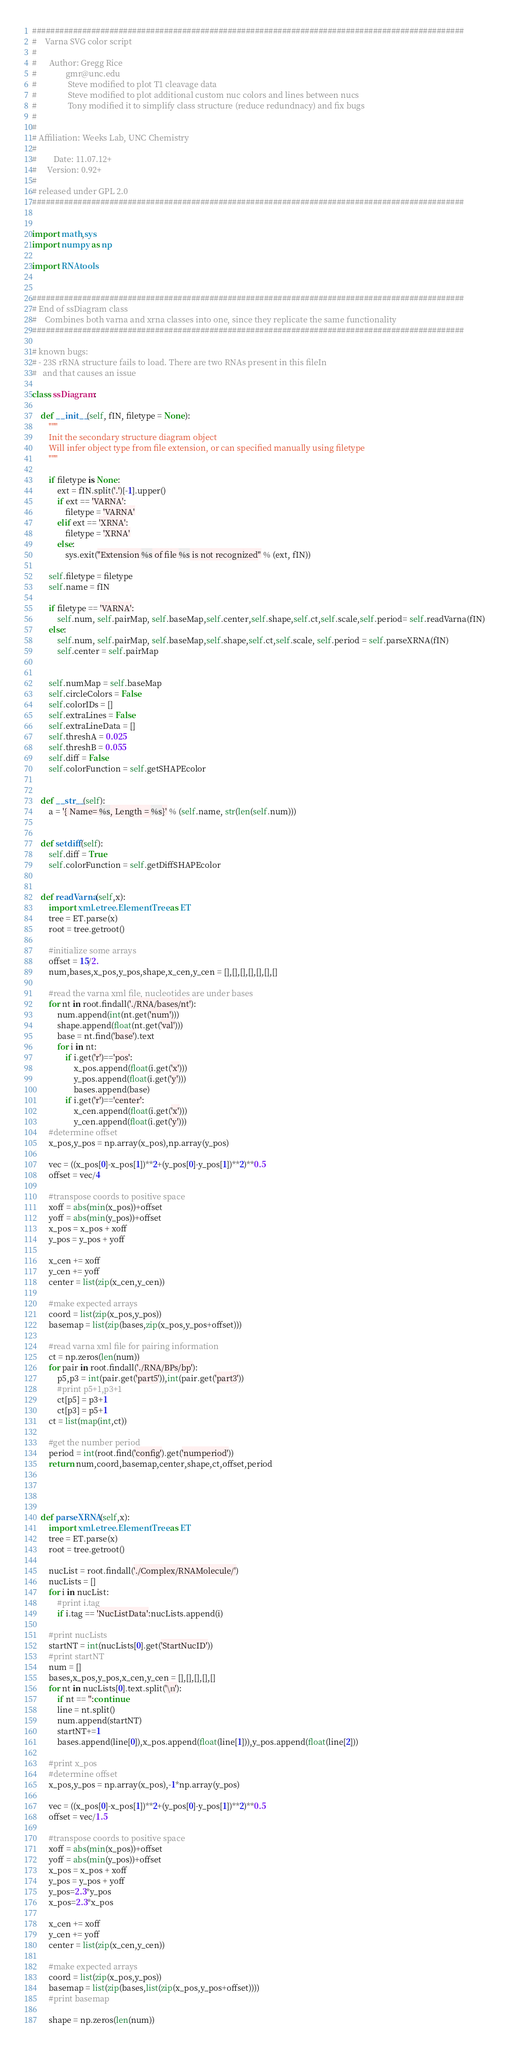<code> <loc_0><loc_0><loc_500><loc_500><_Python_>###############################################################################################
#    Varna SVG color script
#
#      Author: Gregg Rice
#              gmr@unc.edu
#               Steve modified to plot T1 cleavage data
#               Steve modified to plot additional custom nuc colors and lines between nucs
#               Tony modified it to simplify class structure (reduce redundnacy) and fix bugs
#
#
# Affiliation: Weeks Lab, UNC Chemistry
#
#        Date: 11.07.12+
#     Version: 0.92+
#
# released under GPL 2.0
###############################################################################################


import math,sys
import numpy as np

import RNAtools


###############################################################################################
# End of ssDiagram class
#    Combines both varna and xrna classes into one, since they replicate the same functionality
###############################################################################################

# known bugs:
# - 23S rRNA structure fails to load. There are two RNAs present in this fileIn
#   and that causes an issue

class ssDiagram:

    def __init__(self, fIN, filetype = None):
        """
        Init the secondary structure diagram object
        Will infer object type from file extension, or can specified manually using filetype
        """

        if filetype is None:
            ext = fIN.split('.')[-1].upper()
            if ext == 'VARNA':
                filetype = 'VARNA'
            elif ext == 'XRNA':
                filetype = 'XRNA'
            else:
                sys.exit("Extension %s of file %s is not recognized" % (ext, fIN))

        self.filetype = filetype
        self.name = fIN

        if filetype == 'VARNA':
            self.num, self.pairMap, self.baseMap,self.center,self.shape,self.ct,self.scale,self.period= self.readVarna(fIN)
        else:
            self.num, self.pairMap, self.baseMap,self.shape,self.ct,self.scale, self.period = self.parseXRNA(fIN)
            self.center = self.pairMap


        self.numMap = self.baseMap
        self.circleColors = False
        self.colorIDs = []
        self.extraLines = False
        self.extraLineData = []
        self.threshA = 0.025
        self.threshB = 0.055
        self.diff = False
        self.colorFunction = self.getSHAPEcolor


    def __str__(self):
        a = '{ Name= %s, Length = %s}' % (self.name, str(len(self.num)))


    def setdiff(self):
        self.diff = True
        self.colorFunction = self.getDiffSHAPEcolor


    def readVarna(self,x):
        import xml.etree.ElementTree as ET
        tree = ET.parse(x)
        root = tree.getroot()

        #initialize some arrays
        offset = 15/2.
        num,bases,x_pos,y_pos,shape,x_cen,y_cen = [],[],[],[],[],[],[]

        #read the varna xml file, nucleotides are under bases
        for nt in root.findall('./RNA/bases/nt'):
            num.append(int(nt.get('num')))
            shape.append(float(nt.get('val')))
            base = nt.find('base').text
            for i in nt:
                if i.get('r')=='pos':
                    x_pos.append(float(i.get('x')))
                    y_pos.append(float(i.get('y')))
                    bases.append(base)
                if i.get('r')=='center':
                    x_cen.append(float(i.get('x')))
                    y_cen.append(float(i.get('y')))
        #determine offset
        x_pos,y_pos = np.array(x_pos),np.array(y_pos)

        vec = ((x_pos[0]-x_pos[1])**2+(y_pos[0]-y_pos[1])**2)**0.5
        offset = vec/4

        #transpose coords to positive space
        xoff = abs(min(x_pos))+offset
        yoff = abs(min(y_pos))+offset
        x_pos = x_pos + xoff
        y_pos = y_pos + yoff

        x_cen += xoff
        y_cen += yoff
        center = list(zip(x_cen,y_cen))

        #make expected arrays
        coord = list(zip(x_pos,y_pos))
        basemap = list(zip(bases,zip(x_pos,y_pos+offset)))

        #read varna xml file for pairing information
        ct = np.zeros(len(num))
        for pair in root.findall('./RNA/BPs/bp'):
            p5,p3 = int(pair.get('part5')),int(pair.get('part3'))
            #print p5+1,p3+1
            ct[p5] = p3+1
            ct[p3] = p5+1
        ct = list(map(int,ct))

        #get the number period
        period = int(root.find('config').get('numperiod'))
        return num,coord,basemap,center,shape,ct,offset,period




    def parseXRNA(self,x):
        import xml.etree.ElementTree as ET
        tree = ET.parse(x)
        root = tree.getroot()

        nucList = root.findall('./Complex/RNAMolecule/')
        nucLists = []
        for i in nucList:
            #print i.tag
            if i.tag == 'NucListData':nucLists.append(i)

        #print nucLists
        startNT = int(nucLists[0].get('StartNucID'))
        #print startNT
        num = []
        bases,x_pos,y_pos,x_cen,y_cen = [],[],[],[],[]
        for nt in nucLists[0].text.split('\n'):
            if nt == '':continue
            line = nt.split()
            num.append(startNT)
            startNT+=1
            bases.append(line[0]),x_pos.append(float(line[1])),y_pos.append(float(line[2]))

        #print x_pos
        #determine offset
        x_pos,y_pos = np.array(x_pos),-1*np.array(y_pos)

        vec = ((x_pos[0]-x_pos[1])**2+(y_pos[0]-y_pos[1])**2)**0.5
        offset = vec/1.5

        #transpose coords to positive space
        xoff = abs(min(x_pos))+offset
        yoff = abs(min(y_pos))+offset
        x_pos = x_pos + xoff
        y_pos = y_pos + yoff
        y_pos=2.3*y_pos
        x_pos=2.3*x_pos

        x_cen += xoff
        y_cen += yoff
        center = list(zip(x_cen,y_cen))

        #make expected arrays
        coord = list(zip(x_pos,y_pos))
        basemap = list(zip(bases,list(zip(x_pos,y_pos+offset))))
        #print basemap

        shape = np.zeros(len(num))</code> 